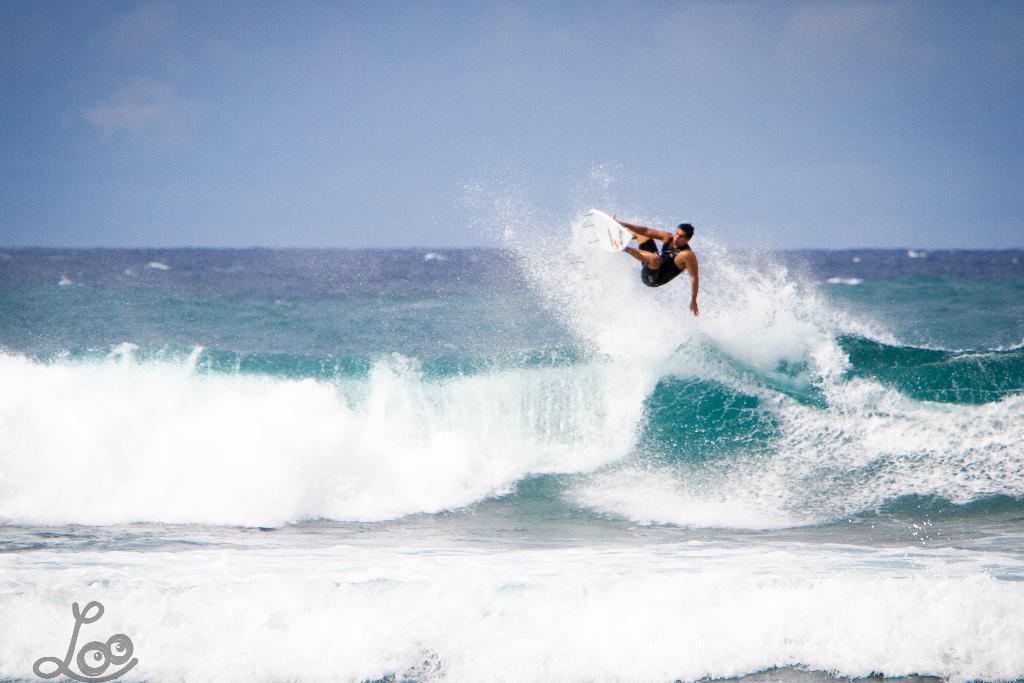Could you give a brief overview of what you see in this image? In the picture i can see a person wearing black color dress doing surfing on waves and the surfing board is of white color and in the background of the picture there is water, there is clear sky. 